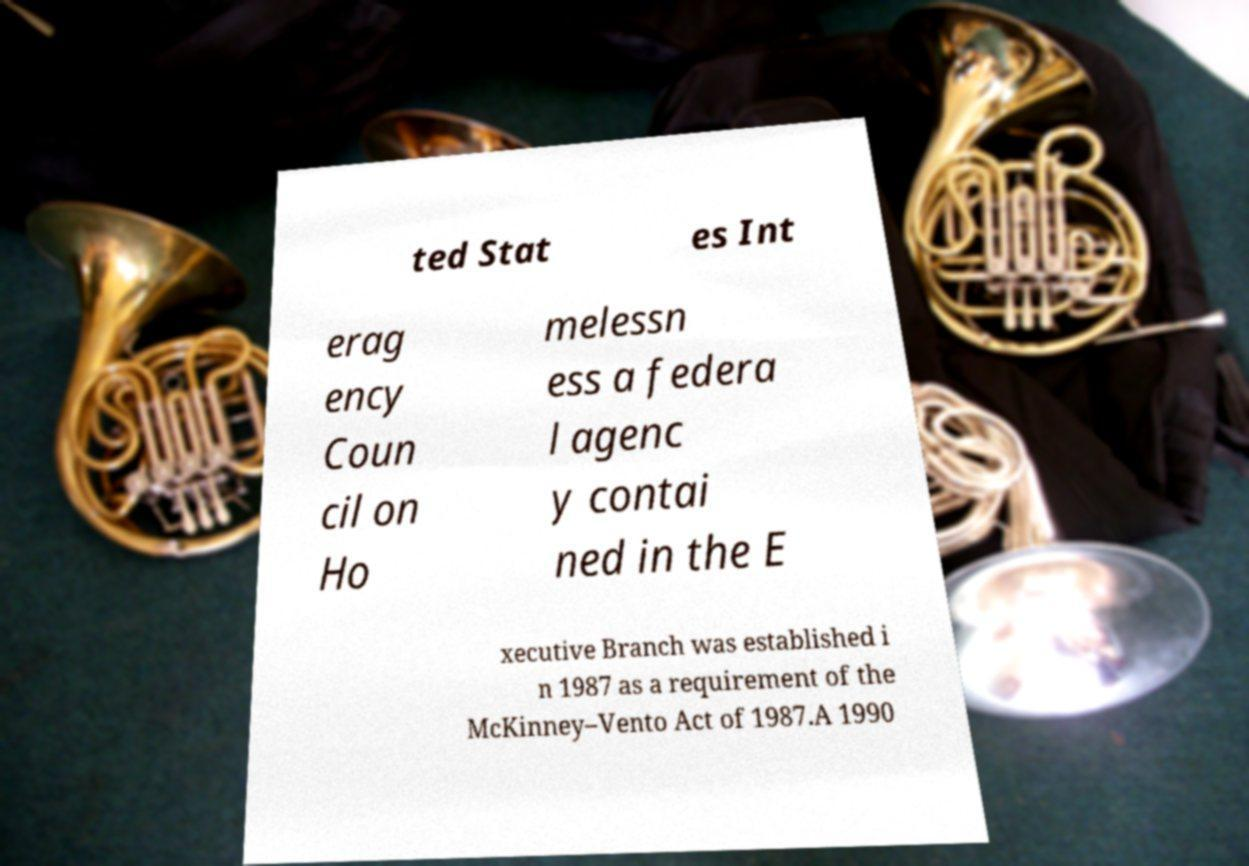Could you extract and type out the text from this image? ted Stat es Int erag ency Coun cil on Ho melessn ess a federa l agenc y contai ned in the E xecutive Branch was established i n 1987 as a requirement of the McKinney–Vento Act of 1987.A 1990 